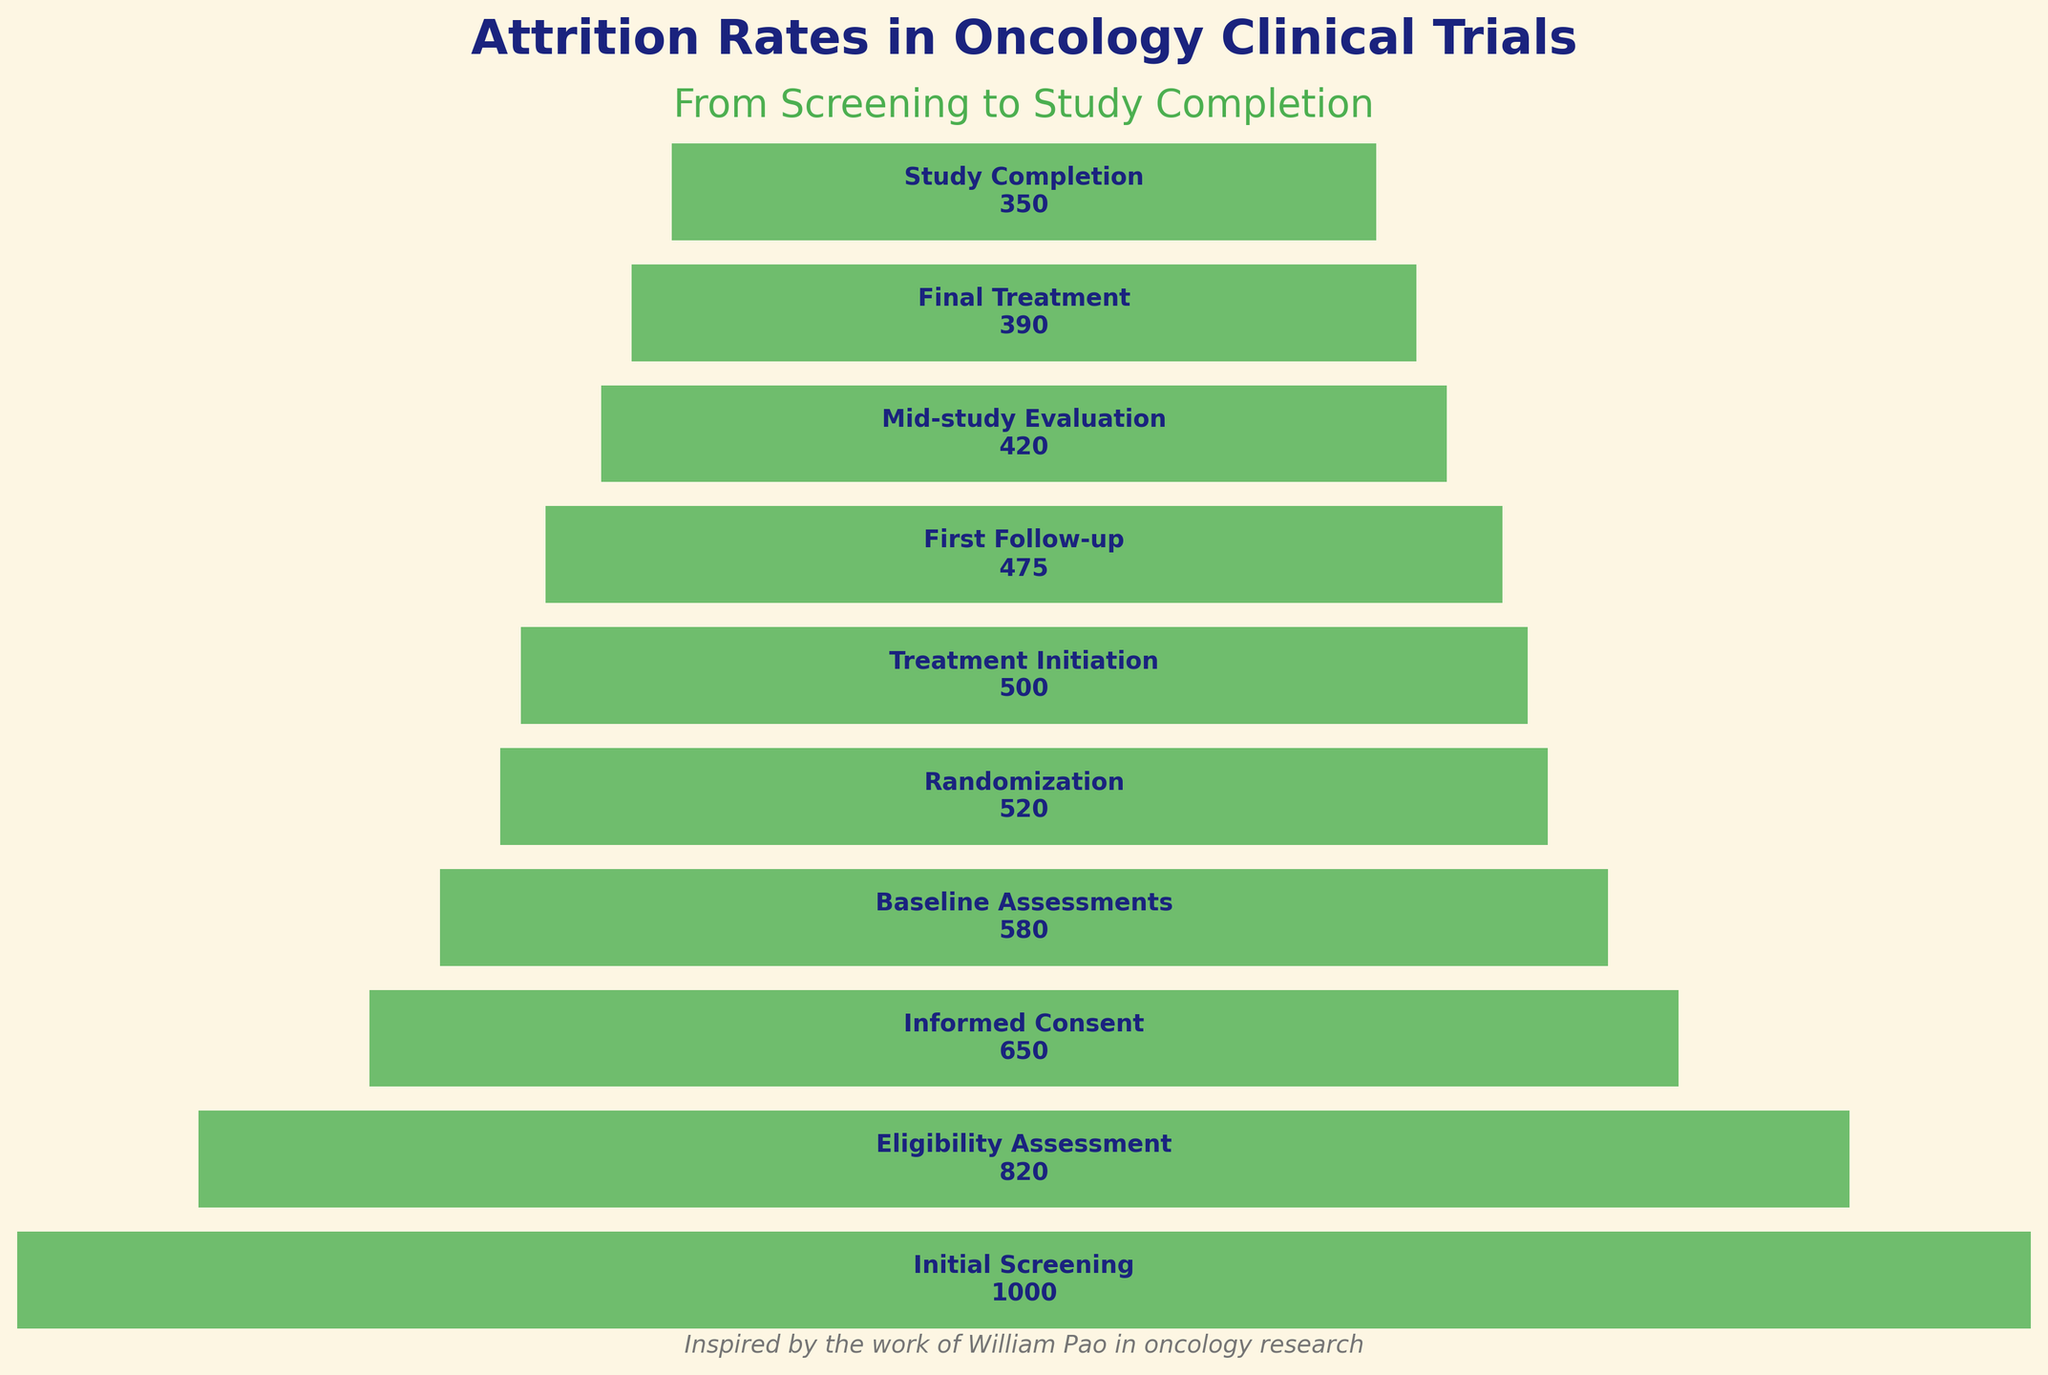What is the title of the funnel chart? The title is typically at the top of the figure, often in larger font size and bolder text compared to other text elements. Here, it is "Attrition Rates in Oncology Clinical Trials".
Answer: Attrition Rates in Oncology Clinical Trials How many stages are present from screening to study completion? Each stage is represented as a separate bar in the funnel chart. Count the number of bars or stage labels.
Answer: 10 What is the number of patients at the Baseline Assessments stage? Locate the bar labeled "Baseline Assessments" in the funnel chart. The number of patients is usually written inside the bar.
Answer: 580 Which stage has the highest number of patients? Identify the stage at the top of the chart as it signifies the initial stage with the highest patient count.
Answer: Initial Screening How many patients were lost between Initial Screening and Eligibility Assessment? Subtract the number of patients at the Eligibility Assessment stage from those at the Initial Screening stage (1000 - 820).
Answer: 180 What is the difference in patient numbers between Treatment Initiation and Final Treatment? Subtract the number of patients at the Final Treatment stage from those at the Treatment Initiation stage (500 - 390).
Answer: 110 Which stage shows the steepest drop in the number of patients? Look for the largest decrease in patient numbers between consecutive stages. The drop can be visualized by the difference in bar widths.
Answer: Initial Screening to Eligibility Assessment What percentage of patients completed the study out of those who started the Treatment Initiation stage? Divide the number of patients at Study Completion by the number at Treatment Initiation and multiply by 100 (350 / 500 * 100).
Answer: 70% Between which stages is the attrition rate lowest? Compare the drop in patient numbers between consecutive stages and identify the smallest decline.
Answer: Treatment Initiation to First Follow-up How many patients are present at the Mid-study Evaluation stage? Locate the bar labeled "Mid-study Evaluation" and note the number of patients indicated inside the bar.
Answer: 420 